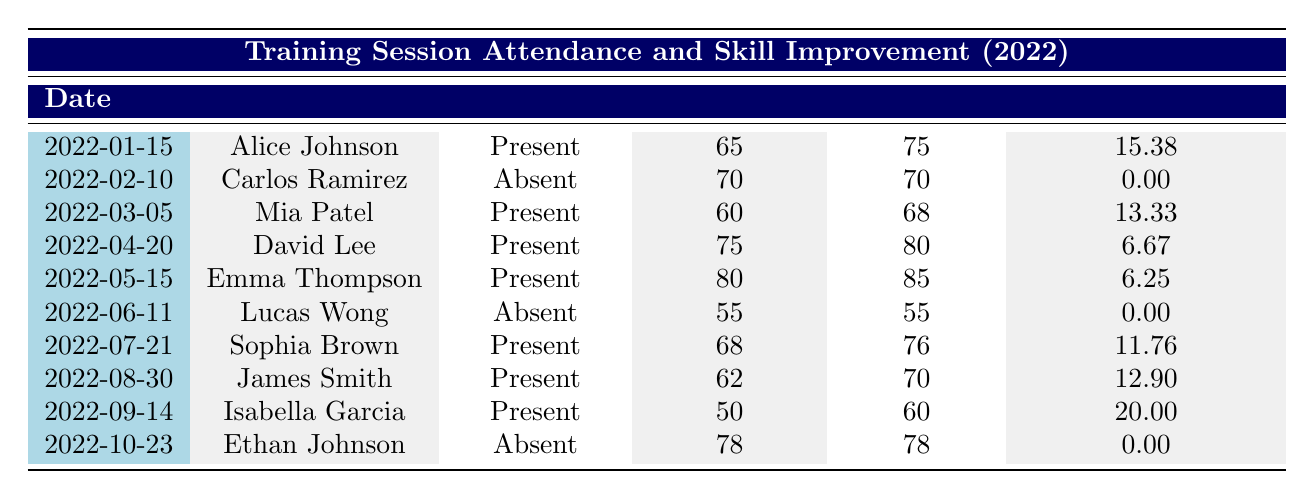What was the skill improvement percentage for Mia Patel? Mia Patel's skill improvement percentage is listed in the table under the respective row for her session, showing an improvement percentage of 13.33.
Answer: 13.33 How many players attended the training sessions? By counting the rows where attendance is marked as "Present," we find that there are 7 players who attended the training sessions.
Answer: 7 What was the average skill improvement percentage for all players who were present? Adding the improvement percentages of all present players: 15.38 + 13.33 + 6.67 + 6.25 + 11.76 + 12.90 + 20 = 86.29. Then, dividing by the number of present players (7): 86.29 / 7 = approximately 12.04.
Answer: 12.04 Did any player who attended a training session have zero improvement? By examining the attendance records, both Carlos Ramirez and Lucas Wong were absent, while no present player had zero improvement. Therefore, the answer is no, none had zero improvement.
Answer: No Who had the highest improvement percentage among all players? To find the highest improvement percentage, we compare each player's improvement and see that Isabella Garcia had the highest at 20%.
Answer: 20 What is the difference between the highest and lowest skill improvement percentages? The highest improvement percentage is 20% (Isabella Garcia), and the lowest among present players is 6.25% (Emma Thompson). The difference is calculated as 20 - 6.25 = 13.75.
Answer: 13.75 Was Emma Thompson present at her training session? Emma Thompson's attendance is marked as "Present" in the table, indicating that she did attend the training session.
Answer: Yes How many players had a skill rating of 70 or above before their training session? Observing the table, David Lee, Emma Thompson, and Carlos Ramirez had skill ratings of 75, 80, and 70 respectively, which means there are 3 players who had a rating of 70 or above before their sessions.
Answer: 3 What was the skill rating of Lucas Wong after the training session? The skill rating for Lucas Wong after the training session is listed in the table as 55.
Answer: 55 